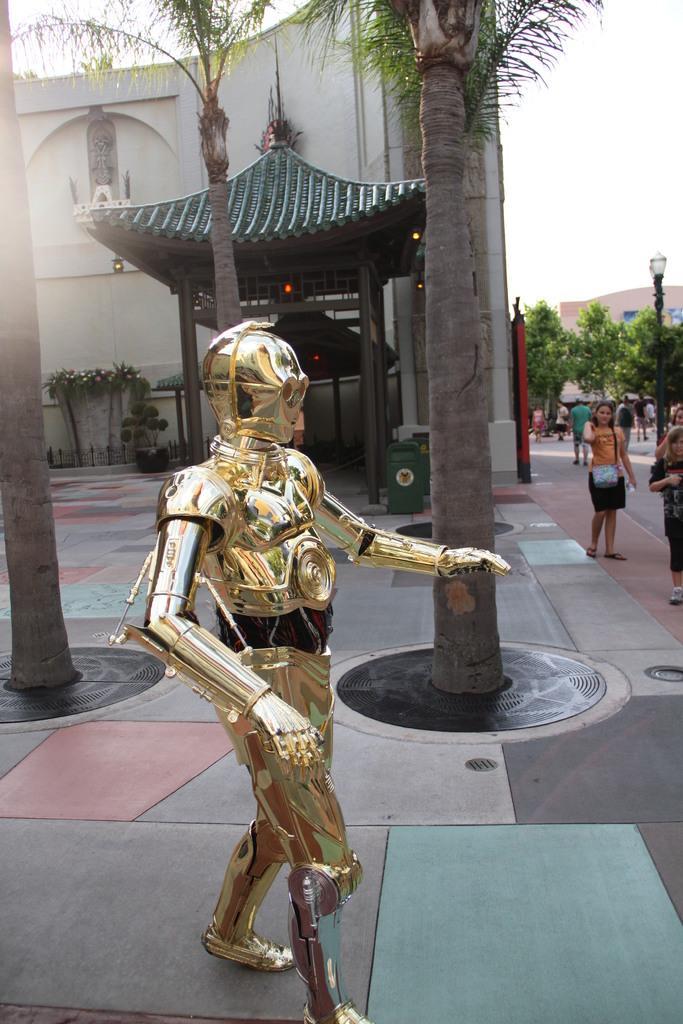Could you give a brief overview of what you see in this image? In this picture I can see there is a metal Armour and in the background I can see there are some people standing and there are some trees, building and the sky is clear. 